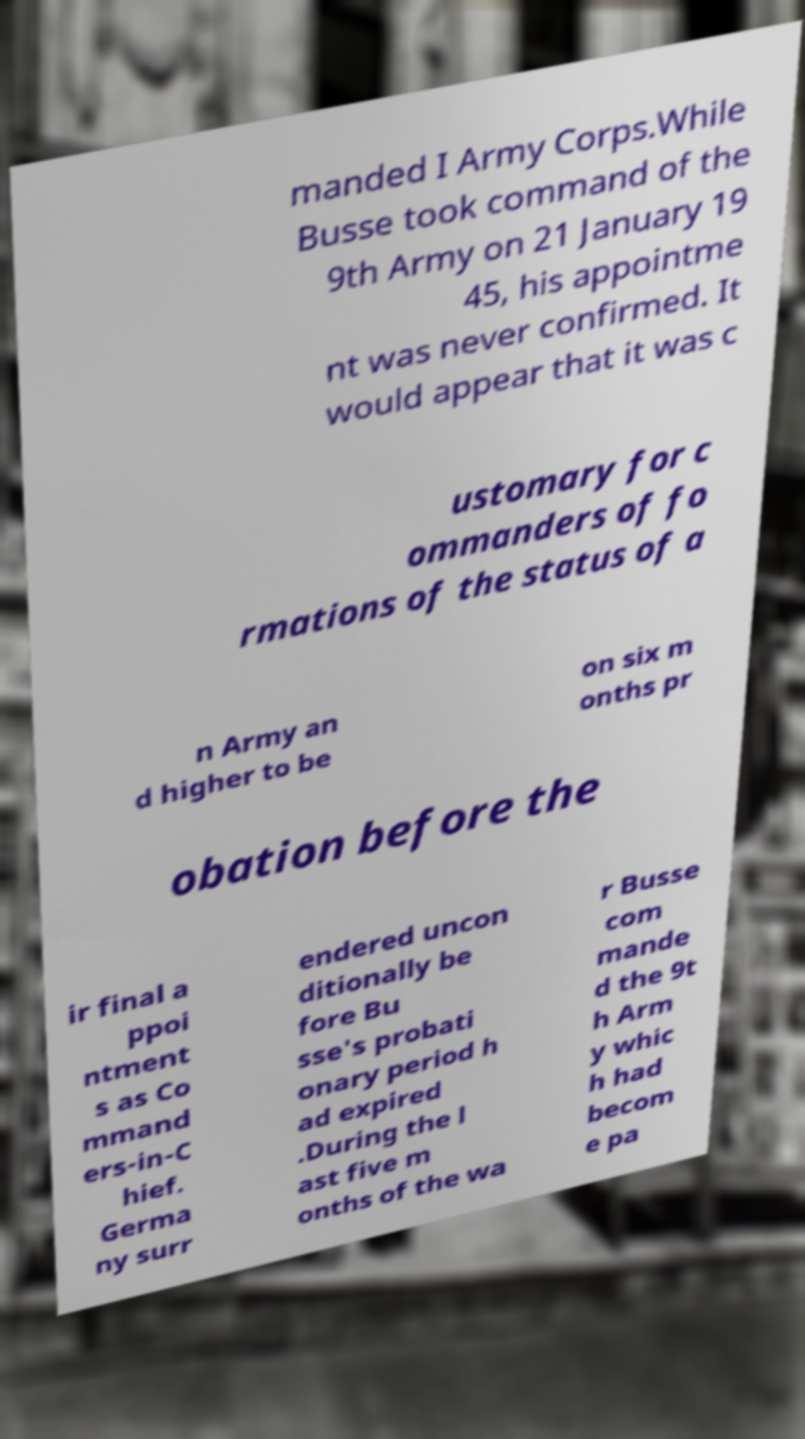Can you accurately transcribe the text from the provided image for me? manded I Army Corps.While Busse took command of the 9th Army on 21 January 19 45, his appointme nt was never confirmed. It would appear that it was c ustomary for c ommanders of fo rmations of the status of a n Army an d higher to be on six m onths pr obation before the ir final a ppoi ntment s as Co mmand ers-in-C hief. Germa ny surr endered uncon ditionally be fore Bu sse's probati onary period h ad expired .During the l ast five m onths of the wa r Busse com mande d the 9t h Arm y whic h had becom e pa 